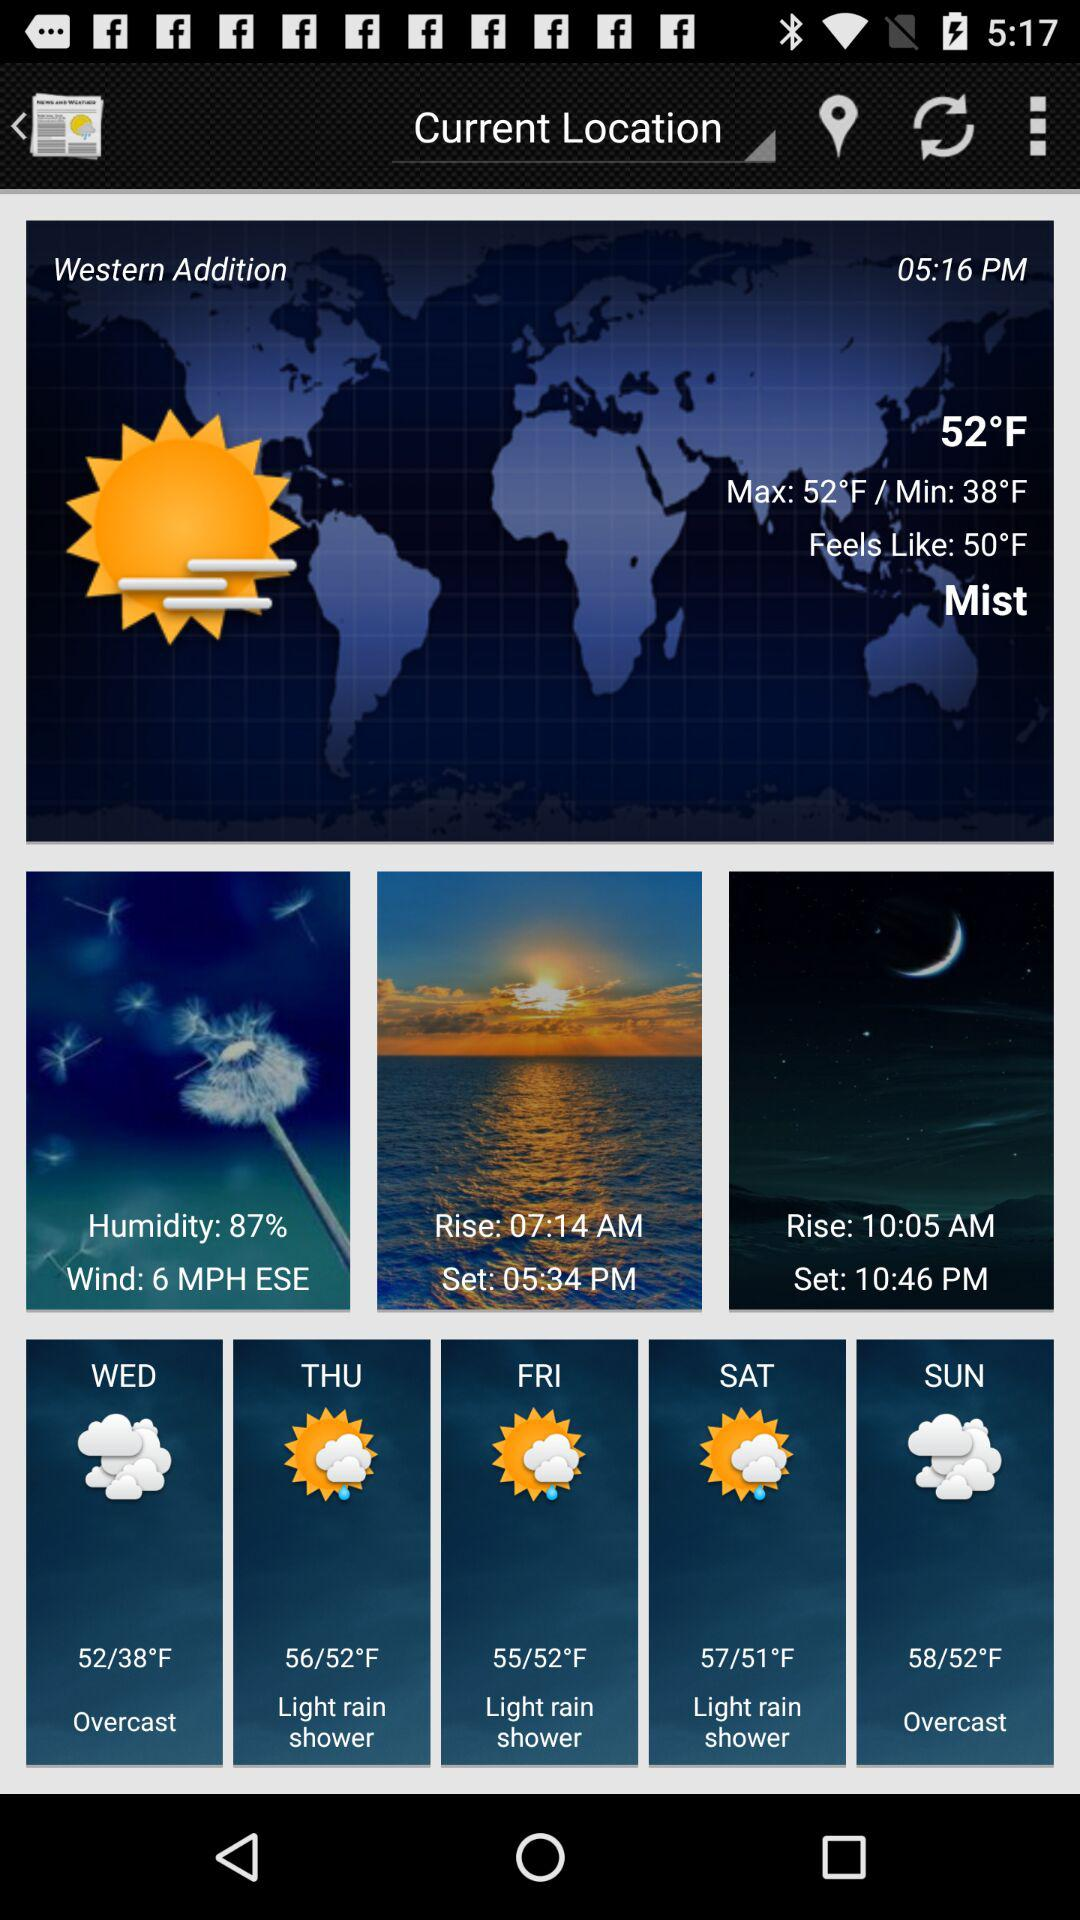How many days are there with a light rain shower?
Answer the question using a single word or phrase. 3 